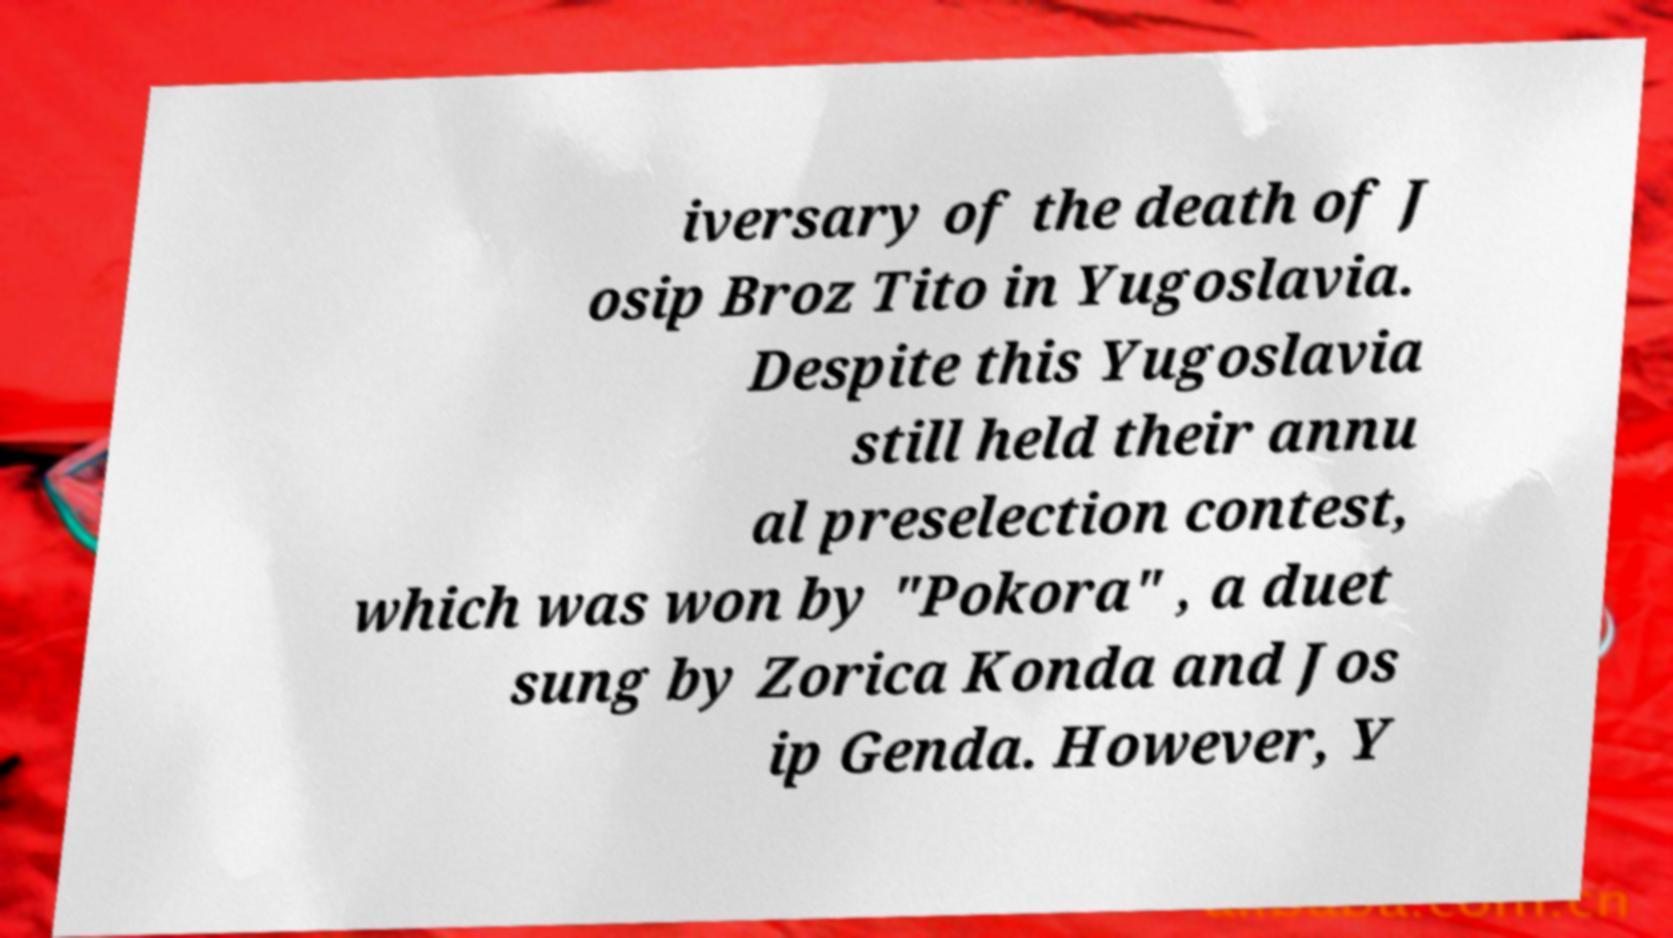Could you assist in decoding the text presented in this image and type it out clearly? iversary of the death of J osip Broz Tito in Yugoslavia. Despite this Yugoslavia still held their annu al preselection contest, which was won by "Pokora" , a duet sung by Zorica Konda and Jos ip Genda. However, Y 